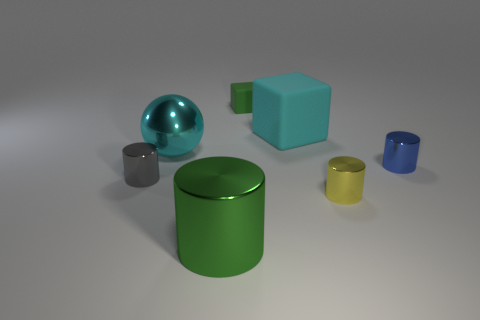What materials do the objects appear to be made of? The objects in the image seem to have a smooth, reflective surface, suggesting they might be made of materials like plastic, metal, or glass, each with a different finish. 